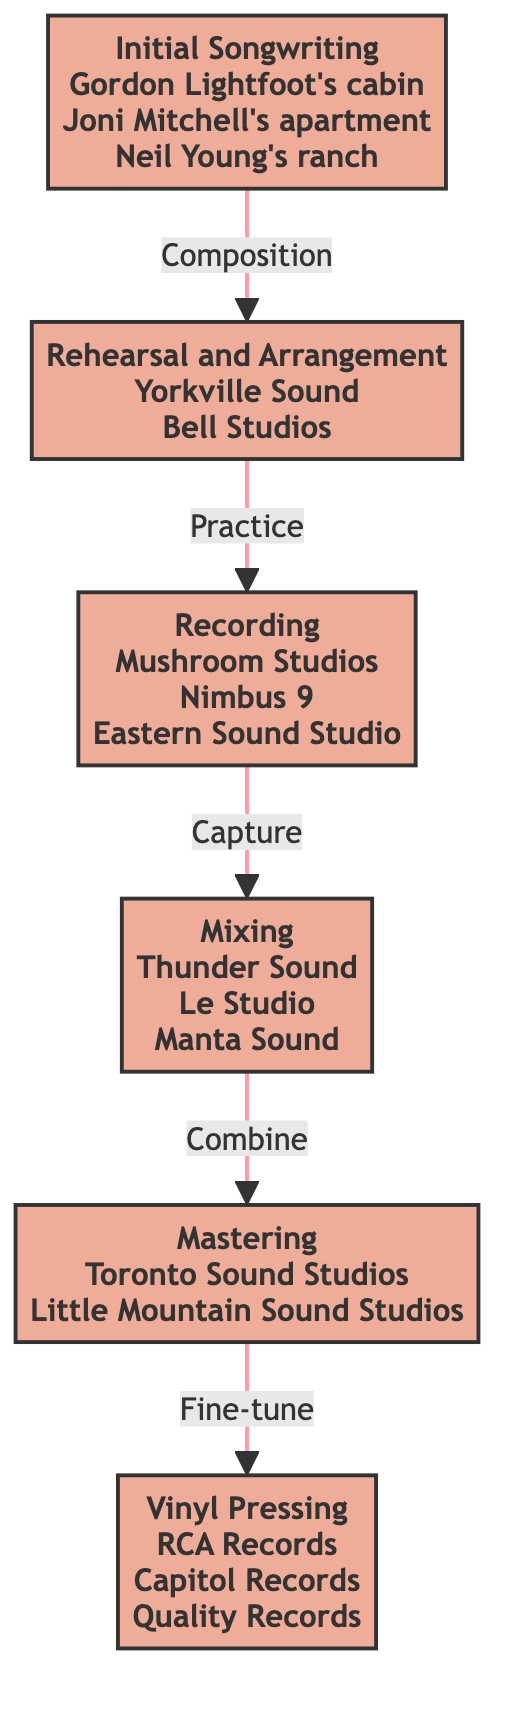What is the first step in the flow of music production? The diagram begins with the node "Initial Songwriting," indicating that this is the first step in the flow of music production.
Answer: Initial Songwriting Which step comes after Recording? Following the node "Recording," the next step in the flow is "Mixing," which is connected directly from Recording.
Answer: Mixing How many steps are there in the music production process? Counting all the distinct nodes in the flowchart, there are six steps laid out from Initial Songwriting to Vinyl Pressing.
Answer: Six What is the last step in the flow? The endpoint of the flowchart is "Vinyl Pressing," signifying it as the final step of the music production process.
Answer: Vinyl Pressing What do you do after Mixing? The process after Mixing is "Mastering," which is the next node in the flow sequence, indicating the final adjustments to the mix.
Answer: Mastering Which two studios are mentioned for Mastering? The nodes connected to Mastering list "Toronto Sound Studios" and "Little Mountain Sound Studios" as examples of places where mastering can take place.
Answer: Toronto Sound Studios, Little Mountain Sound Studios How does the flow of music production progress from Rehearsal and Arrangement? From "Rehearsal and Arrangement," the flow proceeds to "Recording," showing that once the arrangements are finalized, the next action is to capture the performance.
Answer: Recording What is the purpose of the Mixing step? The purpose of Mixing is described in the diagram as "Combining multi-track recordings into a final stereo track," which summarizes what occurs during this phase.
Answer: Combining multi-track recordings What is indicated by the links between the nodes in this flowchart? The links represent the directional flow and sequence of the music production process from one phase to another, showing the progression of steps.
Answer: Directional flow 